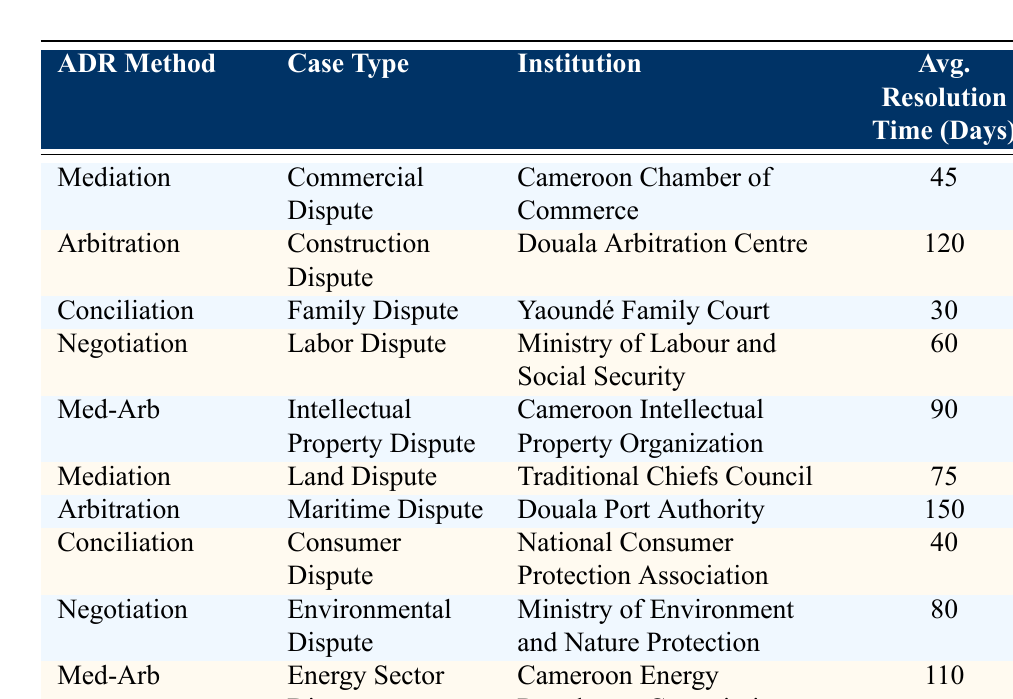What is the average resolution time for disputes using mediation? There are two mediation cases listed: Commercial Dispute (45 days) and Land Dispute (75 days). To find the average, sum the resolution times (45 + 75 = 120), then divide by the number of cases (120 / 2 = 60).
Answer: 60 Which ADR method has the longest average resolution time? The table indicates that the Maritime Dispute arbitration has the longest resolution time at 150 days, which is higher than all other listed methods.
Answer: Arbitration How many days does it take on average to resolve family disputes through conciliation? The table lists one conciliation case for Family Dispute with an average resolution time of 30 days. Therefore, the answer is directly derived from that entry.
Answer: 30 Is the average resolution time for negotiation higher than that for mediation? The average resolution time for negotiation (80 days) is compared with the average for mediation (60 days). Since 80 > 60, the answer is yes.
Answer: Yes What is the total average resolution time for all ADR methods listed? To find the total average resolution time, sum the individual average times: (45 + 120 + 30 + 60 + 90 + 75 + 150 + 40 + 80 + 110 = 900). Then divide by the number of ADR methods (10), resulting in an average of 90.
Answer: 90 Which ADR method is used for consumer disputes? The table shows that conciliation is the method used for consumer disputes, as indicated by the entry for Consumer Dispute under the Conciliation method.
Answer: Conciliation If mediation resolves commercial disputes in an average of 45 days, how much longer does it take to resolve a labor dispute through negotiation? The average resolution time for negotiation is 60 days. To find how much longer it takes compared to mediation, subtract (60 - 45 = 15). Thus, a labor dispute takes 15 days longer.
Answer: 15 days How many methods listed have an average resolution time of more than 100 days? The table shows two methods with resolution times over 100 days: Arbitration for Maritime Dispute (150 days) and Med-Arb for Energy Sector Dispute (110 days). Therefore, 2 methods exceed 100 days.
Answer: 2 methods What is the institution involved in resolving construction disputes? According to the table, the Douala Arbitration Centre is designated for resolving construction disputes through arbitration.
Answer: Douala Arbitration Centre Calculate the difference in average resolution time between arbitration for construction disputes and mediation for commercial disputes. Arbitration for construction disputes has an average time of 120 days, while mediation for commercial disputes is 45 days. Therefore, the difference is (120 - 45 = 75) days.
Answer: 75 days 